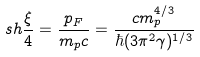<formula> <loc_0><loc_0><loc_500><loc_500>s h \frac { \xi } { 4 } = \frac { p _ { F } } { m _ { p } c } = \frac { c m _ { p } ^ { 4 / 3 } } { \hbar { ( } 3 \pi ^ { 2 } \gamma ) ^ { 1 / 3 } }</formula> 